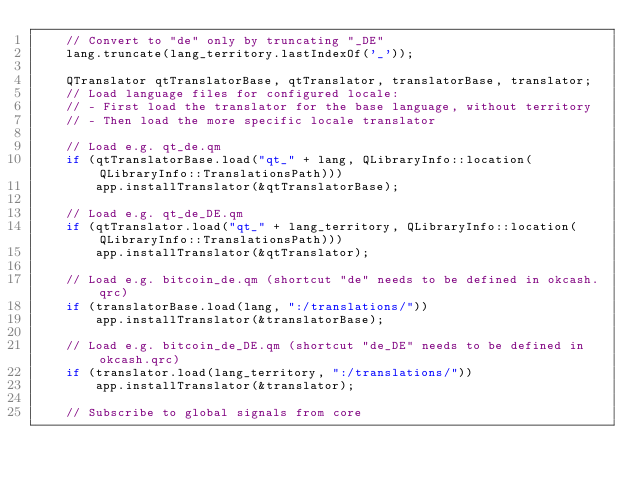Convert code to text. <code><loc_0><loc_0><loc_500><loc_500><_C++_>    // Convert to "de" only by truncating "_DE"
    lang.truncate(lang_territory.lastIndexOf('_'));

    QTranslator qtTranslatorBase, qtTranslator, translatorBase, translator;
    // Load language files for configured locale:
    // - First load the translator for the base language, without territory
    // - Then load the more specific locale translator

    // Load e.g. qt_de.qm
    if (qtTranslatorBase.load("qt_" + lang, QLibraryInfo::location(QLibraryInfo::TranslationsPath)))
        app.installTranslator(&qtTranslatorBase);

    // Load e.g. qt_de_DE.qm
    if (qtTranslator.load("qt_" + lang_territory, QLibraryInfo::location(QLibraryInfo::TranslationsPath)))
        app.installTranslator(&qtTranslator);

    // Load e.g. bitcoin_de.qm (shortcut "de" needs to be defined in okcash.qrc)
    if (translatorBase.load(lang, ":/translations/"))
        app.installTranslator(&translatorBase);

    // Load e.g. bitcoin_de_DE.qm (shortcut "de_DE" needs to be defined in okcash.qrc)
    if (translator.load(lang_territory, ":/translations/"))
        app.installTranslator(&translator);

    // Subscribe to global signals from core</code> 